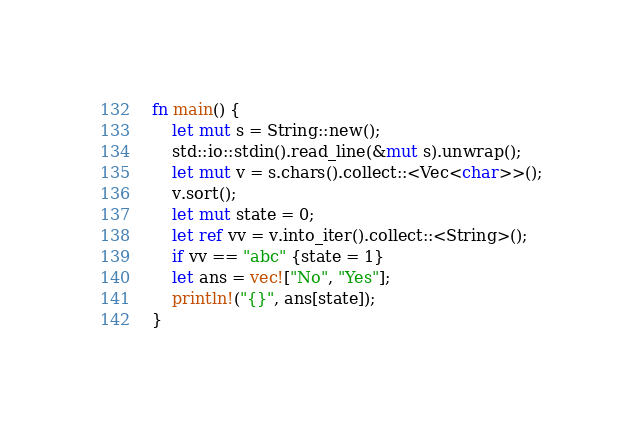Convert code to text. <code><loc_0><loc_0><loc_500><loc_500><_Rust_>fn main() {
    let mut s = String::new();
    std::io::stdin().read_line(&mut s).unwrap();
    let mut v = s.chars().collect::<Vec<char>>();
    v.sort();
    let mut state = 0;
    let ref vv = v.into_iter().collect::<String>();
    if vv == "abc" {state = 1}
    let ans = vec!["No", "Yes"];
    println!("{}", ans[state]);
}
</code> 